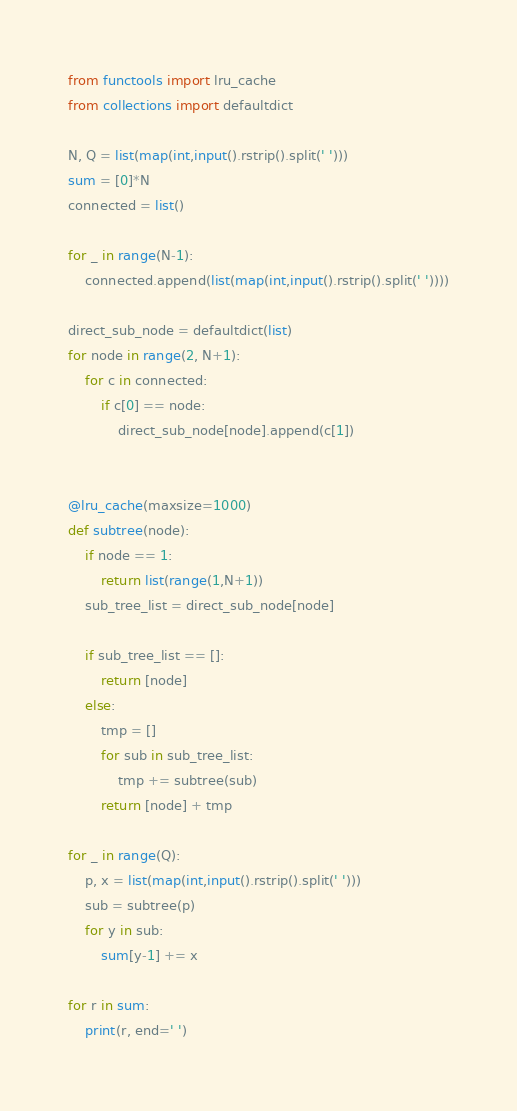<code> <loc_0><loc_0><loc_500><loc_500><_Python_>from functools import lru_cache
from collections import defaultdict

N, Q = list(map(int,input().rstrip().split(' ')))
sum = [0]*N
connected = list()

for _ in range(N-1):
    connected.append(list(map(int,input().rstrip().split(' '))))

direct_sub_node = defaultdict(list)
for node in range(2, N+1):
    for c in connected:
        if c[0] == node:
            direct_sub_node[node].append(c[1])


@lru_cache(maxsize=1000)
def subtree(node):
    if node == 1:
        return list(range(1,N+1))
    sub_tree_list = direct_sub_node[node]

    if sub_tree_list == []:
        return [node]
    else:
        tmp = []
        for sub in sub_tree_list:
            tmp += subtree(sub)
        return [node] + tmp

for _ in range(Q):
    p, x = list(map(int,input().rstrip().split(' ')))
    sub = subtree(p)
    for y in sub:
        sum[y-1] += x

for r in sum:
    print(r, end=' ')</code> 